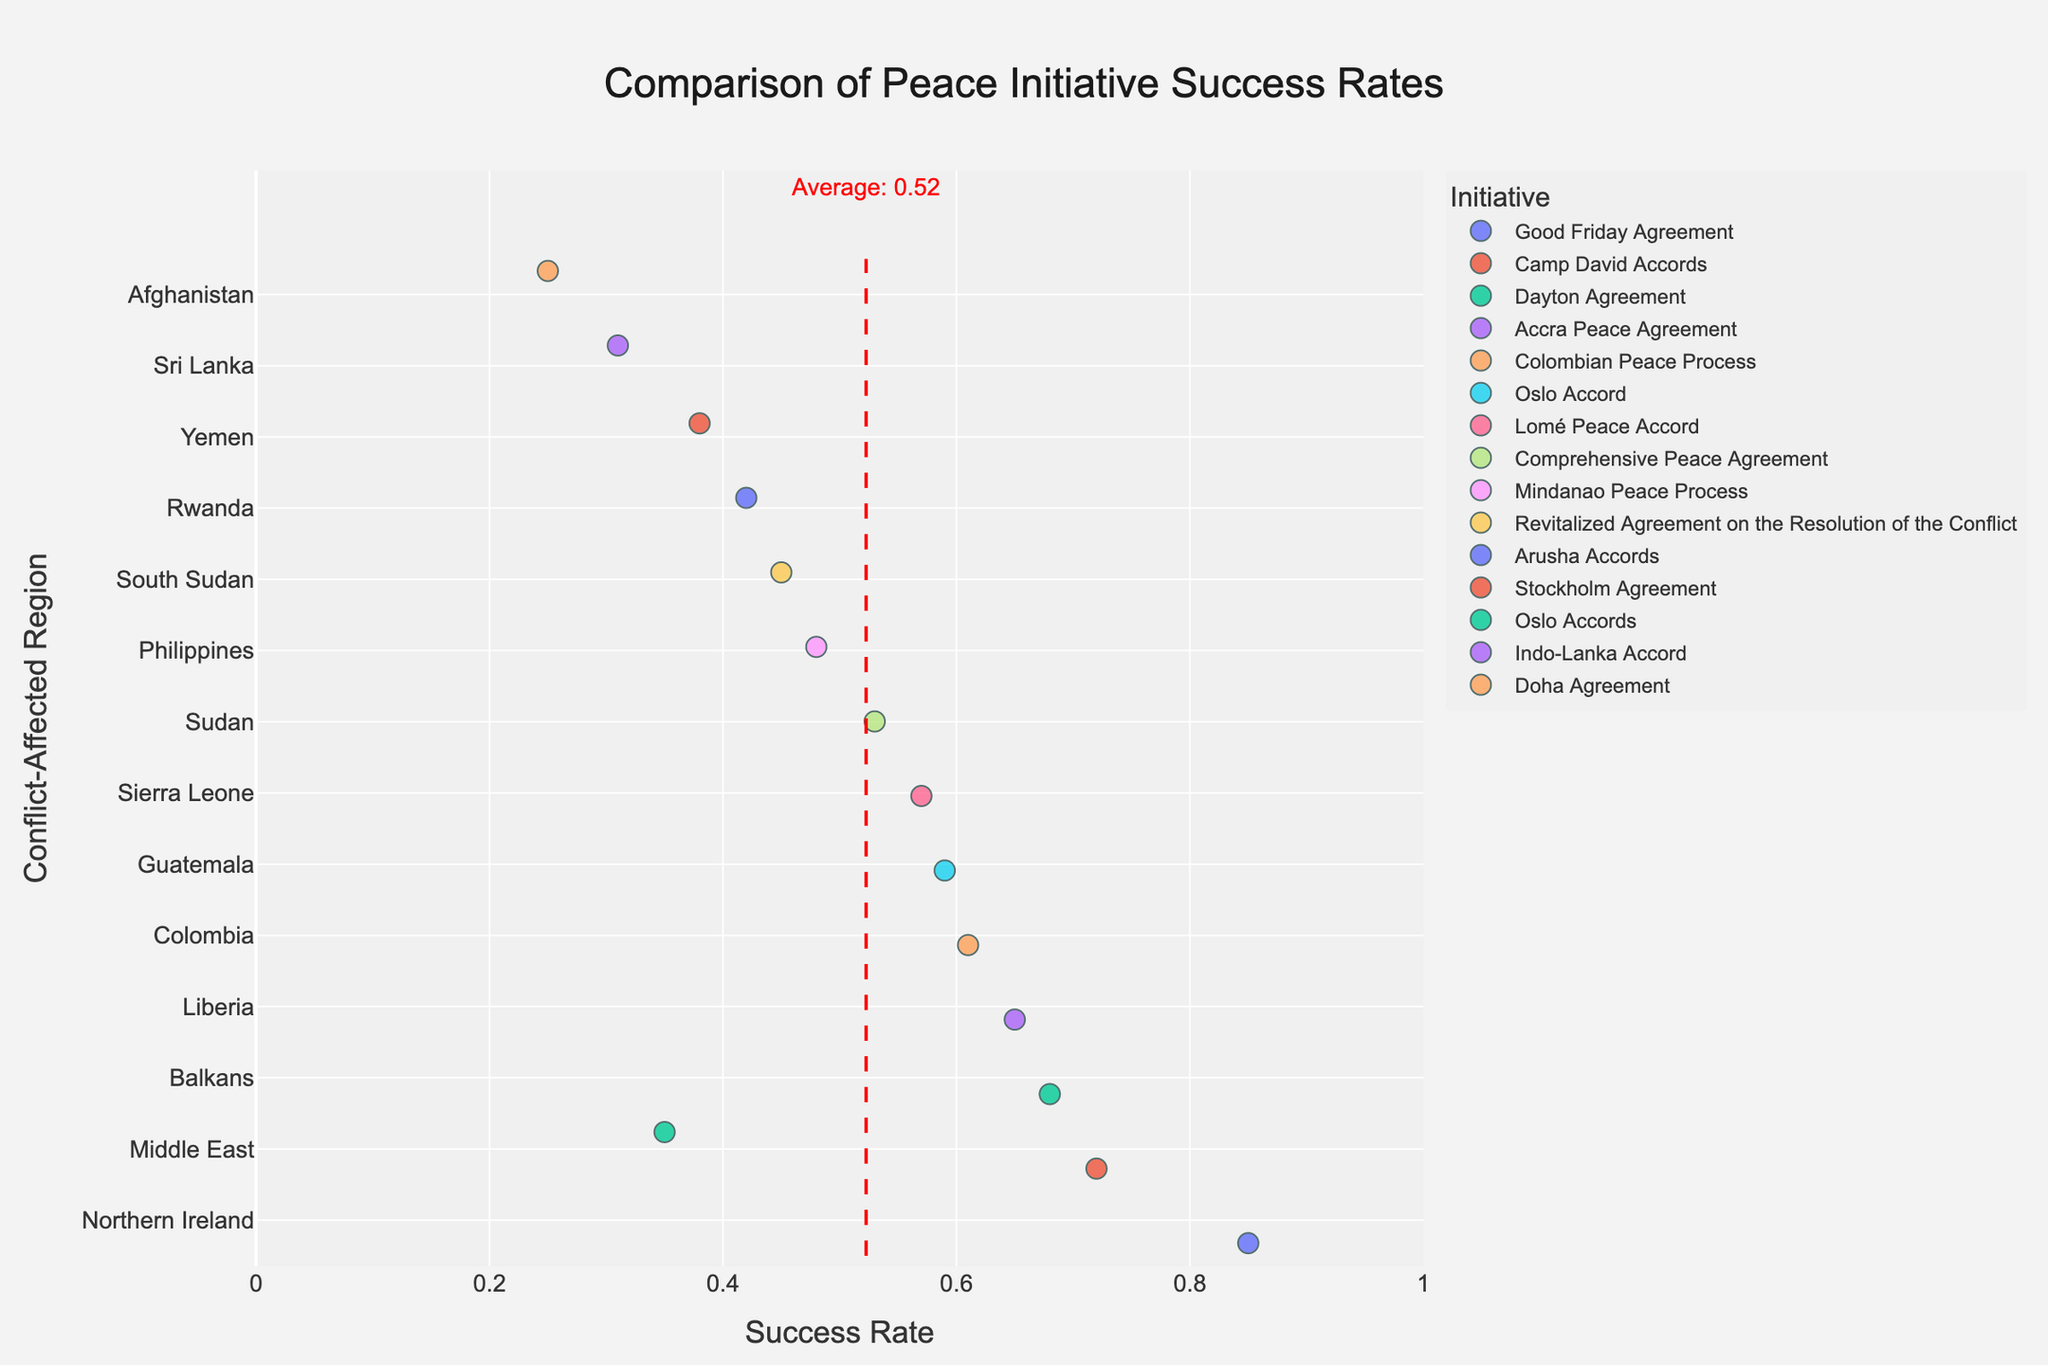What's the title of the plot? The title is displayed at the top of the figure. It clearly states the main theme of the plot.
Answer: Comparison of Peace Initiative Success Rates What is the highest success rate and which peace initiative does it correspond to? Look for the highest data point on the x-axis and observe its corresponding initiative.
Answer: 0.85, Good Friday Agreement Which region has the most peace initiatives represented in the plot? Count the number of initiatives (colored points) associated with each region on the y-axis.
Answer: Middle East What is the average success rate of the peace initiatives displayed? Observe the red dotted line intersecting the x-axis and note the annotated value.
Answer: 0.52 How does the success rate of the Oslo Accord in Guatemala compare to the Oslo Accords in the Middle East? Locate the initiatives on the y-axis and compare their success rates along the x-axis.
Answer: Oslo Accord in Guatemala: 0.59, Oslo Accords in Middle East: 0.35 Which regions have peace initiatives with a success rate below 0.40? Identify all points on the left side of the 0.40 marker on the x-axis and note their corresponding regions.
Answer: Sri Lanka, Afghanistan, Yemen Is there a region where all peace initiatives have success rates above the average success rate? Compare the success rates of each region's initiatives to the red average line.
Answer: Northern Ireland What is the difference in success rates between the Good Friday Agreement and the Indo-Lanka Accord? Subtract the success rate of the Indo-Lanka Accord from that of the Good Friday Agreement.
Answer: 0.85 - 0.31 = 0.54 Which peace initiative in the Middle East had a higher success rate, Oslo Accords or Camp David Accords? Locate both initiatives under 'Middle East' and compare their values on the x-axis.
Answer: Camp David Accords Among the listed initiatives, which region has the peace initiative with the smallest success rate? Find the leftmost point on the x-axis and identify its corresponding region.
Answer: Afghanistan 